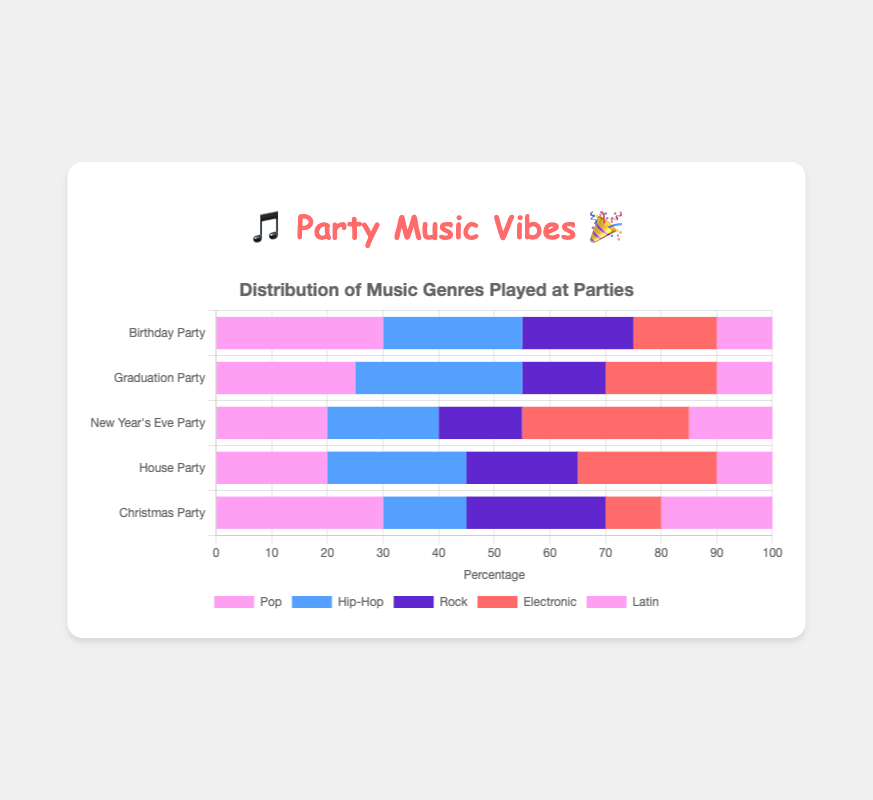Which party has the highest percentage of Hip-Hop music? The chart shows that the Graduation Party has the highest percentage of Hip-Hop music with 30%.
Answer: Graduation Party What is the total percentage of Rock music played across all parties? Sum the Rock music percentages for all parties: 20 (Birthday Party) + 15 (Graduation Party) + 15 (New Year's Eve Party) + 20 (House Party) + 25 (Christmas Party) = 95.
Answer: 95 Compare the popularity of Electronic music between New Year's Eve Party and House Party. The chart shows that Electronic music makes up 30% of New Year's Eve Party and 25% of House Party. 30% is greater than 25%.
Answer: New Year's Eve Party Which genre has the smallest difference in percentage between Birthday Party and Graduation Party? Calculate the differences for each genre: 
- Pop: 30 - 25 = 5 
- Hip-Hop: 30 - 25 = 5 
- Rock: 20 - 15 = 5 
- Electronic: 15 - 20 = 5 
- Latin: 10 - 10 = 0. 
Latin has the smallest difference of 0.
Answer: Latin What are the total percentages of Pop and Electronic music at the Christmas Party? Sum the percentages for Pop and Electronic music at the Christmas Party: 30 (Pop) + 10 (Electronic) = 40.
Answer: 40 Which party has an equal percentage of Rock and Latin music? Check the chart for a party where the percentages of Rock and Latin music are equal. The New Year's Eve Party has 15% Rock and 15% Latin music.
Answer: New Year's Eve Party What is the average percentage of Pop music played across all parties? Sum the Pop music percentages for all parties and divide by the number of parties: (30 + 25 + 20 + 20 + 30) / 5 = 125 / 5 = 25.
Answer: 25 Compare the total percentage of Latin music at Birthday Party and House Party. The chart shows that Birthday Party has 10% Latin music and House Party also has 10%. Therefore, both parties have the same percentage of Latin music.
Answer: Same Which genre is represented by the pinkish-purple color in the chart? Identify the pinkish-purple color in the legend, which corresponds to the Pop genre.
Answer: Pop Which party has the highest diversity in the music genres played? Look for the party where the percentages of different genres are more evenly distributed. The House Party has values that are fairly similar across the genres: 20 (Pop), 25 (Hip-Hop), 20 (Rock), 25 (Electronic), 10 (Latin).
Answer: House Party 